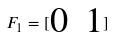<formula> <loc_0><loc_0><loc_500><loc_500>F _ { 1 } = [ \begin{matrix} 0 & 1 \end{matrix} ]</formula> 